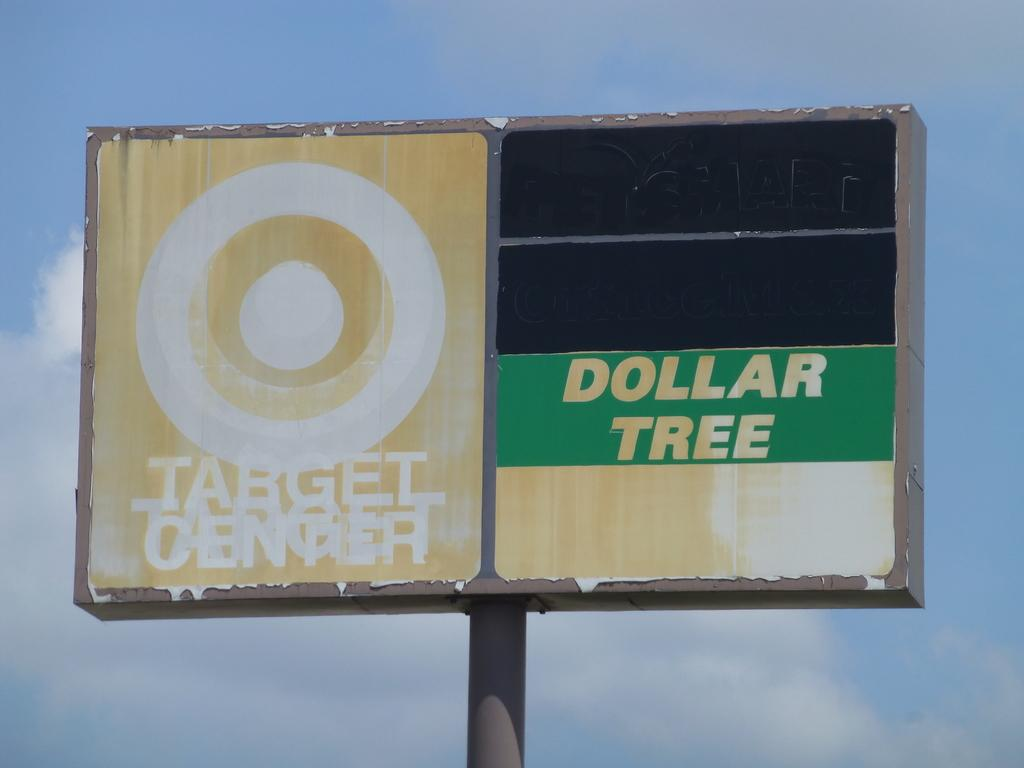Provide a one-sentence caption for the provided image. A very old sign that has since faded of an old Dollar Tree and Target store. 